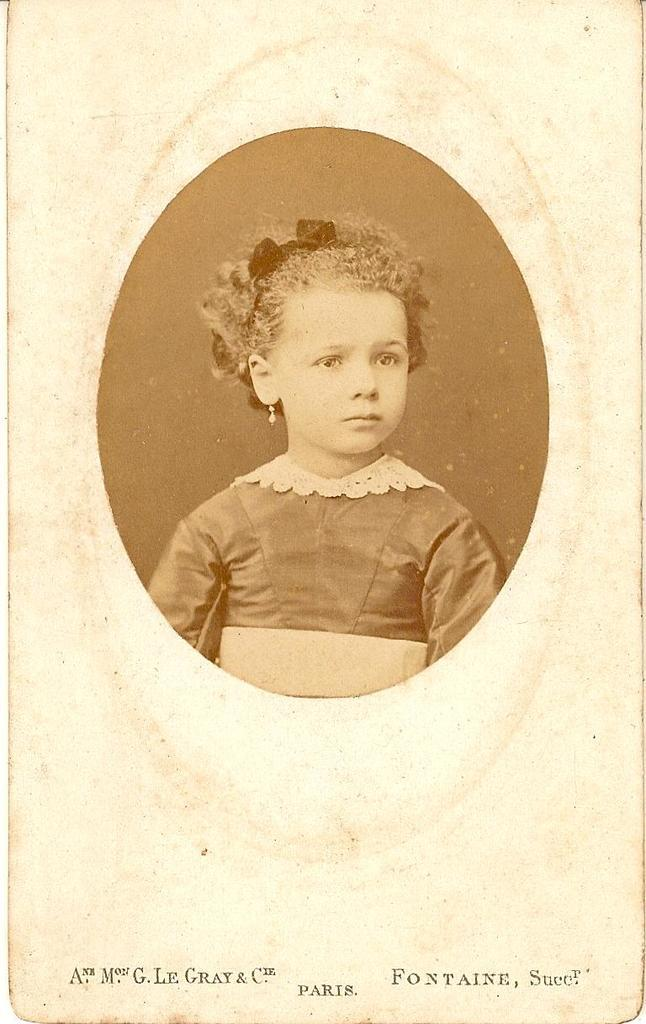What is present in the image that is made of paper? There is a paper in the image. Can you describe the person in the image? There is a woman wearing a dress in the image. What information can be found on the paper? There is a person's name visible on the paper. How many ants can be seen crawling on the woman's dress in the image? There are no ants present in the image; it only features a woman wearing a dress and a paper with a person's name on it. What type of beast is visible in the image? There is no beast present in the image. 